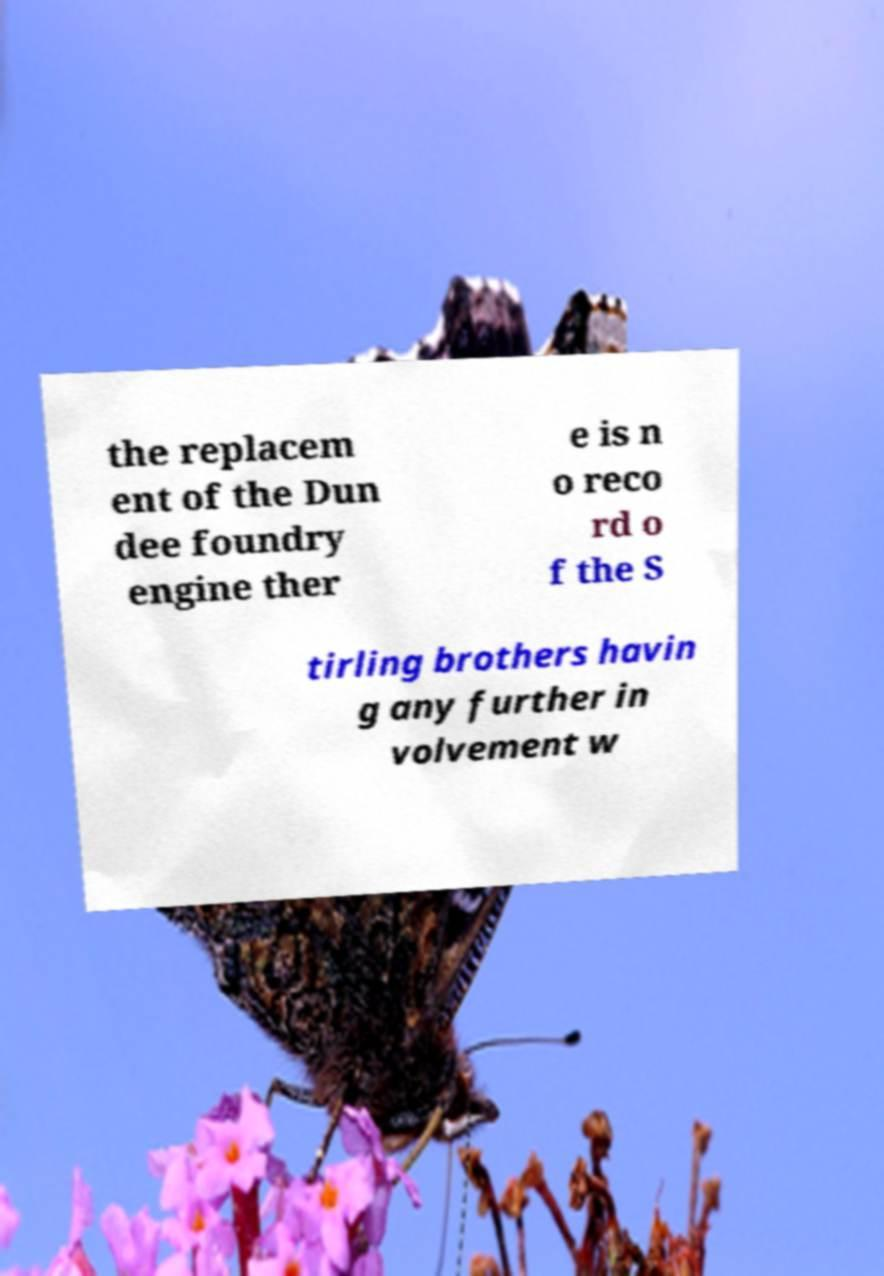Please read and relay the text visible in this image. What does it say? the replacem ent of the Dun dee foundry engine ther e is n o reco rd o f the S tirling brothers havin g any further in volvement w 